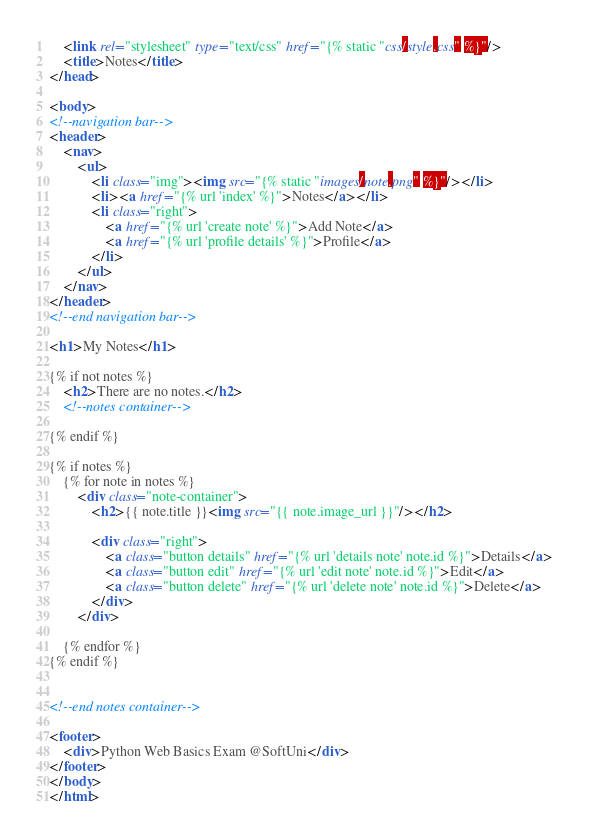<code> <loc_0><loc_0><loc_500><loc_500><_HTML_>    <link rel="stylesheet" type="text/css" href="{% static "css/style.css" %}"/>
    <title>Notes</title>
</head>

<body>
<!--navigation bar-->
<header>
    <nav>
        <ul>
            <li class="img"><img src="{% static "images/note.png" %}"/></li>
            <li><a href="{% url 'index' %}">Notes</a></li>
            <li class="right">
                <a href="{% url 'create note' %}">Add Note</a>
                <a href="{% url 'profile details' %}">Profile</a>
            </li>
        </ul>
    </nav>
</header>
<!--end navigation bar-->

<h1>My Notes</h1>

{% if not notes %}
    <h2>There are no notes.</h2>
    <!--notes container-->

{% endif %}

{% if notes %}
    {% for note in notes %}
        <div class="note-container">
            <h2>{{ note.title }}<img src="{{ note.image_url }}"/></h2>

            <div class="right">
                <a class="button details" href="{% url 'details note' note.id %}">Details</a>
                <a class="button edit" href="{% url 'edit note' note.id %}">Edit</a>
                <a class="button delete" href="{% url 'delete note' note.id %}">Delete</a>
            </div>
        </div>

    {% endfor %}
{% endif %}


<!--end notes container-->

<footer>
    <div>Python Web Basics Exam @SoftUni</div>
</footer>
</body>
</html>
</code> 